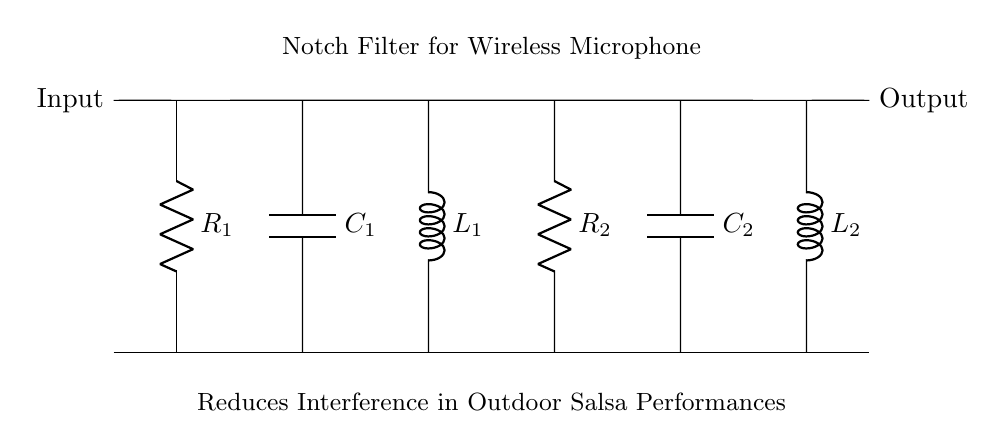What components are in this notch filter circuit? The circuit consists of two resistors, two capacitors, and two inductors, specifically R1, R2, C1, C2, L1, and L2.
Answer: R1, R2, C1, C2, L1, L2 What is the primary function of this circuit? The circuit is a notch filter designed to reduce interference, particularly in wireless microphones used during outdoor salsa performances.
Answer: Reduce interference How many capacitors are used in the circuit? There are two capacitors shown in the circuit diagram (C1 and C2).
Answer: Two Which component is placed first in the signal path? The first component in the signal path is the resistor R1 located at the starting point of the circuit.
Answer: Resistor R1 What is unique about the arrangement of the components in this circuit? The components are arranged in a series configuration that allows for tuning to specific interference frequencies, effectively creating a notch for unwanted signals.
Answer: Series configuration What might happen if one of the inductors fails? If one of the inductors (L1 or L2) fails, it could compromise the filter's ability to attenuate specific frequency bands, potentially allowing more interference through.
Answer: Compromised filtering What is the overall goal of using this notch filter in outdoor performances? The goal is to ensure cleaner wireless audio transmission by minimizing unwanted interference, enhancing the quality of sound in salsa performances.
Answer: Ensure cleaner audio transmission 